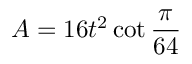Convert formula to latex. <formula><loc_0><loc_0><loc_500><loc_500>A = 1 6 t ^ { 2 } \cot { \frac { \pi } { 6 4 } }</formula> 